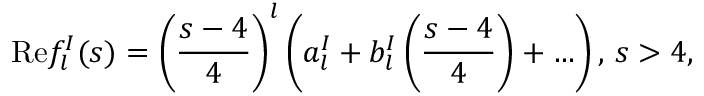<formula> <loc_0><loc_0><loc_500><loc_500>R e f _ { l } ^ { I } ( s ) = \left ( { \frac { s - 4 } { 4 } } \right ) ^ { l } \left ( a _ { l } ^ { I } + b _ { l } ^ { I } \left ( { \frac { s - 4 } { 4 } } \right ) + \dots \right ) , \, s > 4 ,</formula> 